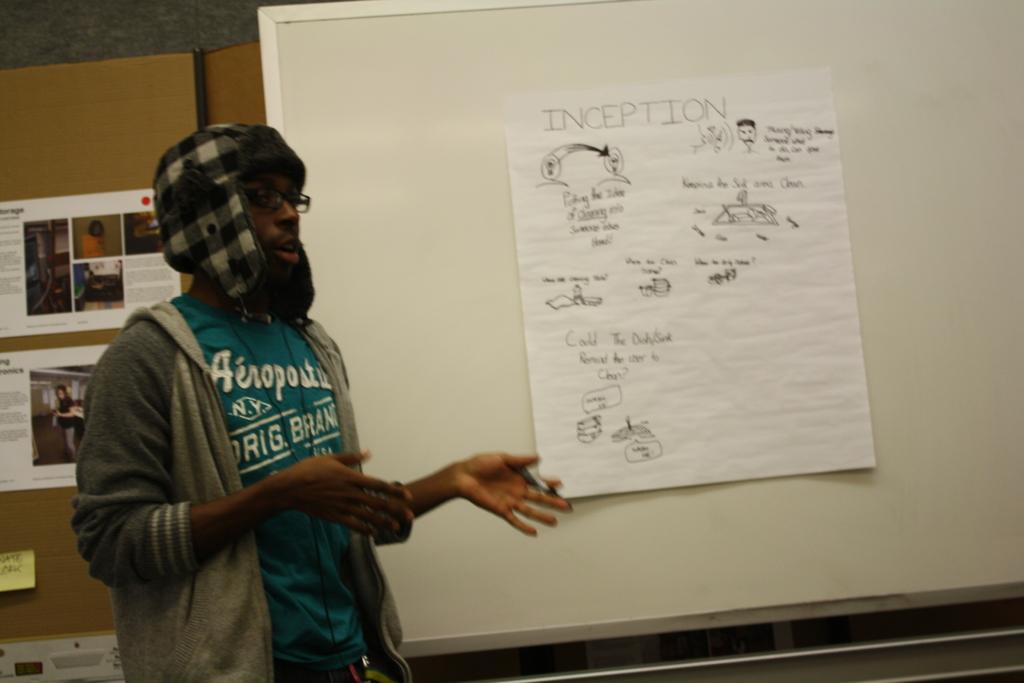What is the top word/name on the shirt?
Your answer should be compact. Aeropostale. 